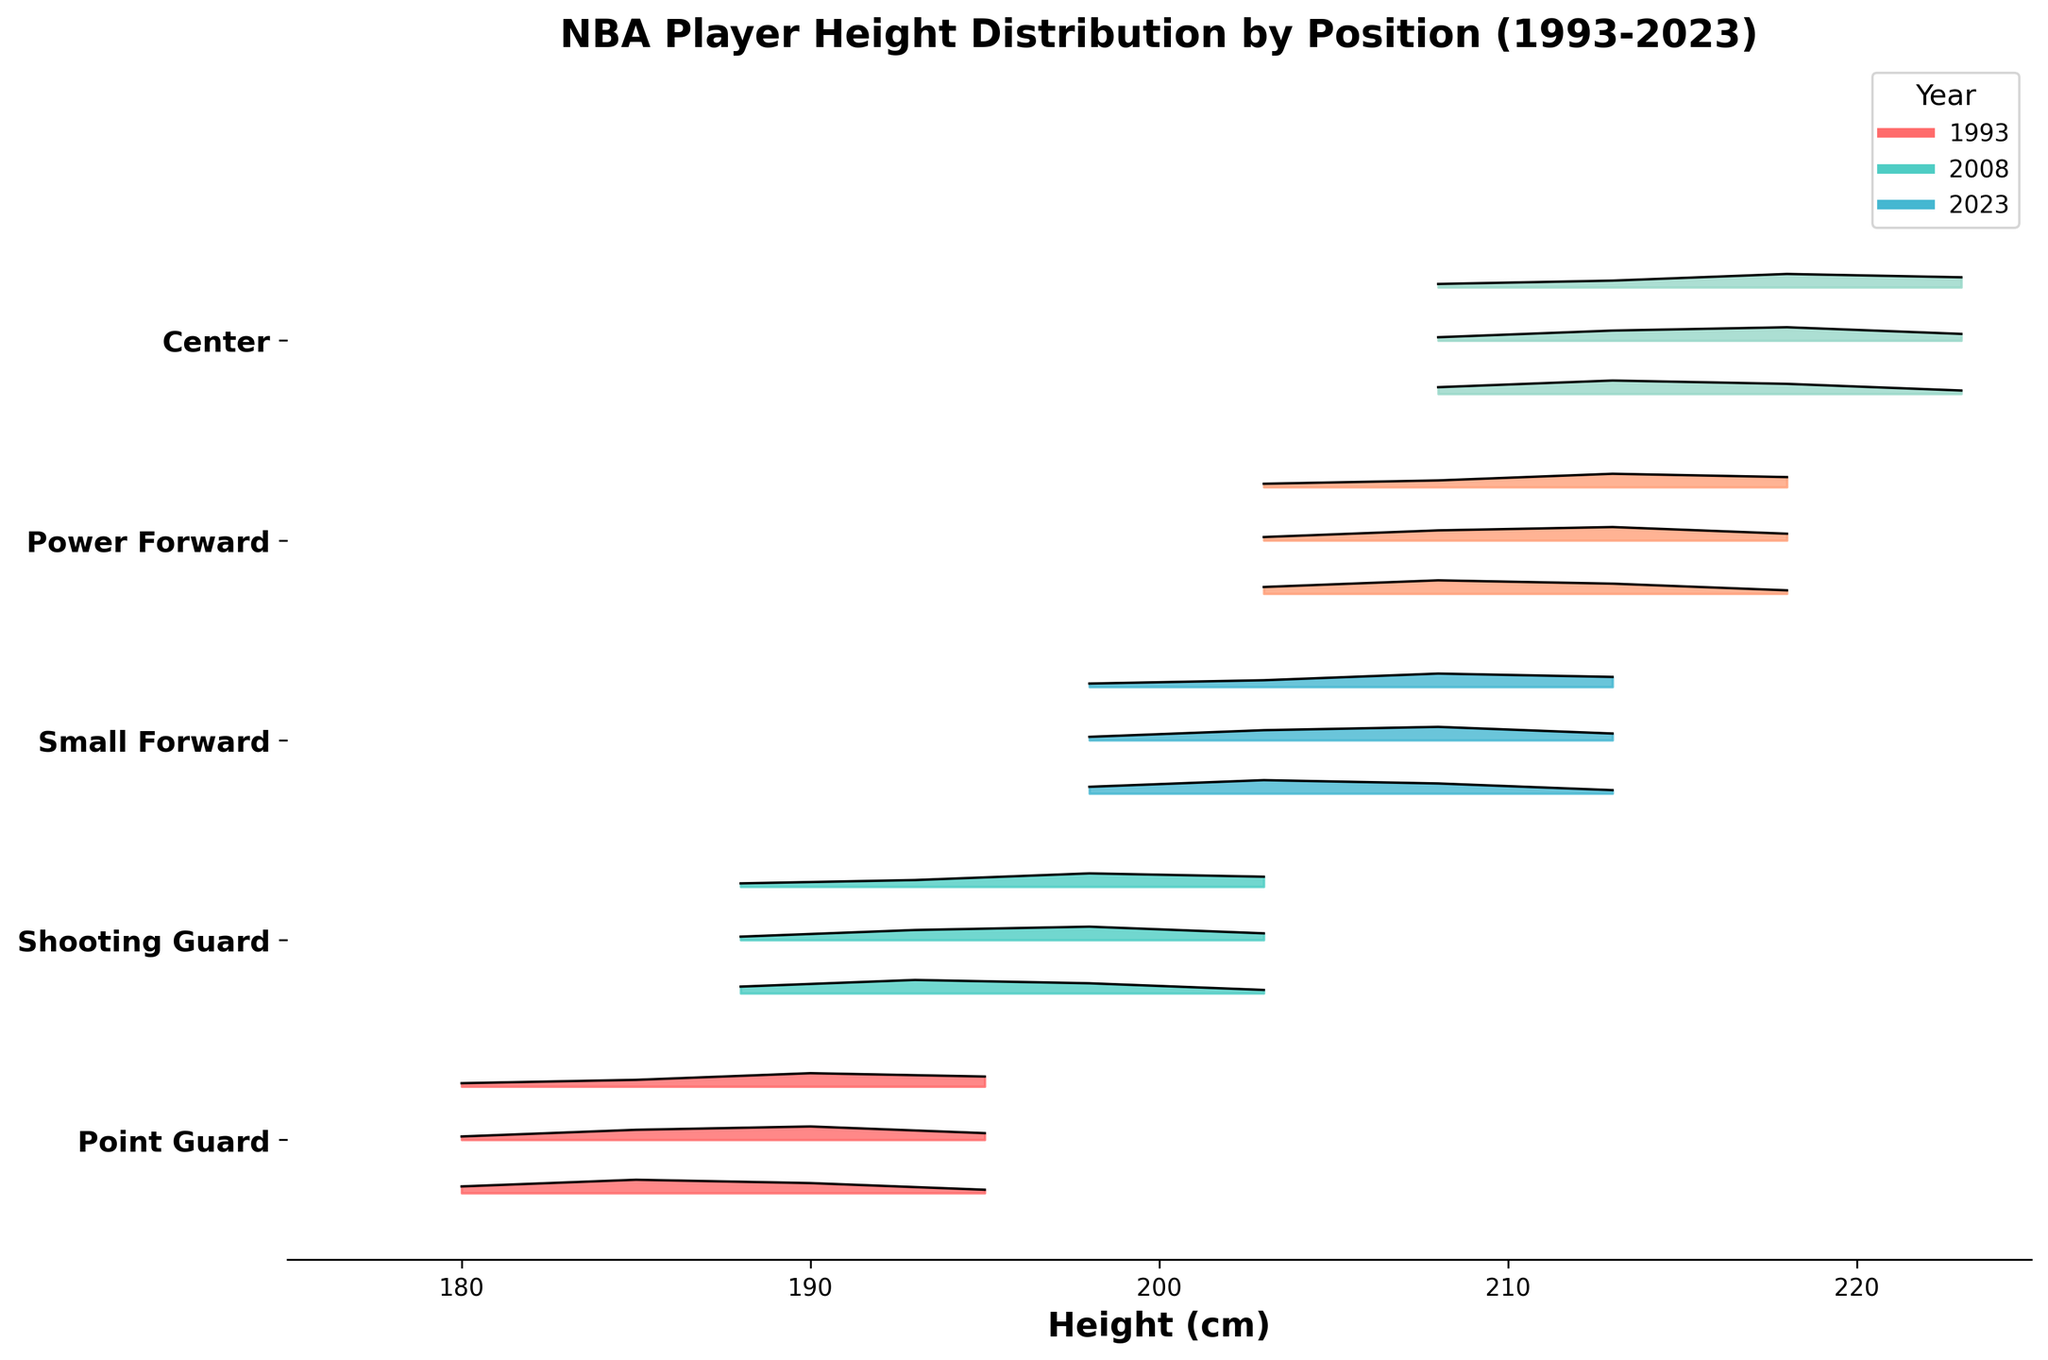What does the title of the plot say? The title of the plot is located at the top of the figure. It is intended to give a quick insight into what the plot is demonstrating. In this case, the title of the plot reads "NBA Player Height Distribution by Position (1993-2023)".
Answer: NBA Player Height Distribution by Position (1993-2023) Which positions are shown in this plot? The y-axis of this Ridgeline plot represents different positions of NBA players. It is labeled with the positions shown in the plot. The positions are Point Guard, Shooting Guard, Small Forward, Power Forward, and Center.
Answer: Point Guard, Shooting Guard, Small Forward, Power Forward, Center What year has the highest density for point guards at 190 cm? To determine this, we need to compare the lines and filled areas for point guards at the height of 190 cm across different years. The highest density is indicated by the peak height of the curve at 190 cm. In this plot, the year 2023 shows the highest density for point guards at 190 cm.
Answer: 2023 How does the height distribution of shooting guards change from 1993 to 2023? By examining the density peaks for shooting guards across the years, we can compare the distribution at specific heights. In 1993, the densities are relatively spread out with a peak at 193 cm. By 2023, densities are more concentrated with the highest density peak also at 198 cm but higher than in 1993. This shows a trend of increased height in shooting guards.
Answer: The height distribution shows increased height concentration by 2023 What is the height range covered by centers in the plot? The x-axis represents the height in cm. For centers, the height range covered is from the lowest density significant point to the highest. According to the plot, this range for centers is from 208 cm to 223 cm.
Answer: 208 cm to 223 cm Which position has the widest range of height distributions in 2023? We need to identify the position with the widest range of significant density points for the year 2023. By looking at the heights of different positions in 2023, the Power Forward position shows a height range from 203 cm to 218 cm, which is the widest range covered.
Answer: Power Forward How does the density of heights for centers at 213 cm change over the years 1993, 2008, and 2023? Comparing the density values of centers at 213 cm across the three years, we see that the density values are 0.04 in 1993, 0.03 in 2008, and 0.02 in 2023. This demonstrates a decreasing trend over the years.
Answer: Decreasing trend Which position had the highest density at any height in 2008 and what was that height? To determine the highest density at any height in 2008, we compare the peaks of each position. The Power Forward position shows a significant peak at 213 cm in 2008 with a density of 0.04.
Answer: Power Forward at 213 cm 